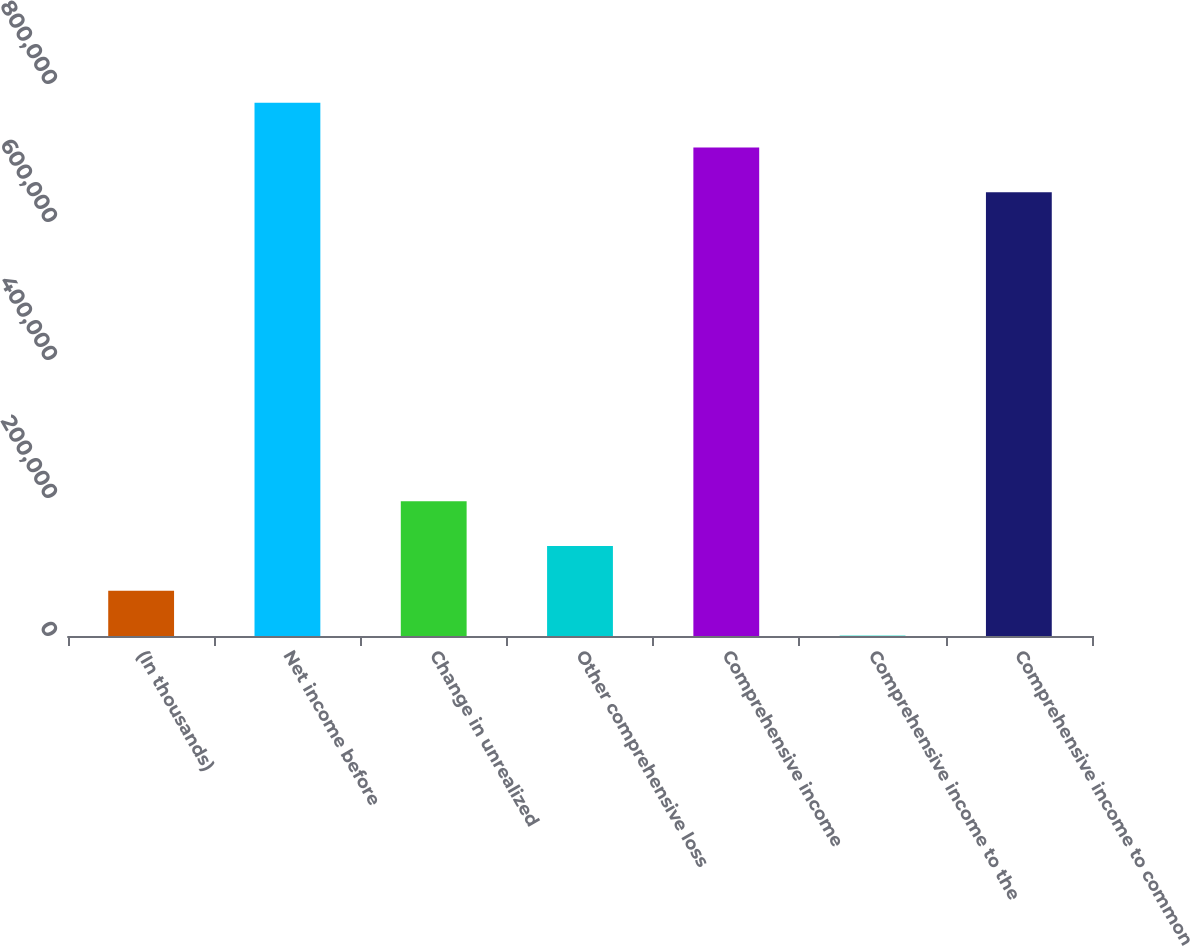Convert chart to OTSL. <chart><loc_0><loc_0><loc_500><loc_500><bar_chart><fcel>(In thousands)<fcel>Net income before<fcel>Change in unrealized<fcel>Other comprehensive loss<fcel>Comprehensive income<fcel>Comprehensive income to the<fcel>Comprehensive income to common<nl><fcel>65637.1<fcel>772813<fcel>195407<fcel>130522<fcel>707928<fcel>752<fcel>643043<nl></chart> 